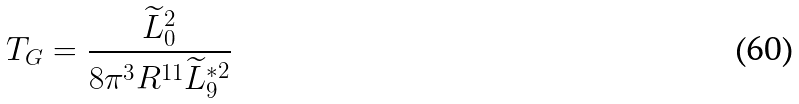<formula> <loc_0><loc_0><loc_500><loc_500>T _ { G } = \frac { \widetilde { L } _ { 0 } ^ { 2 } } { 8 \pi ^ { 3 } R ^ { 1 1 } \widetilde { L } _ { 9 } ^ { \ast 2 } }</formula> 